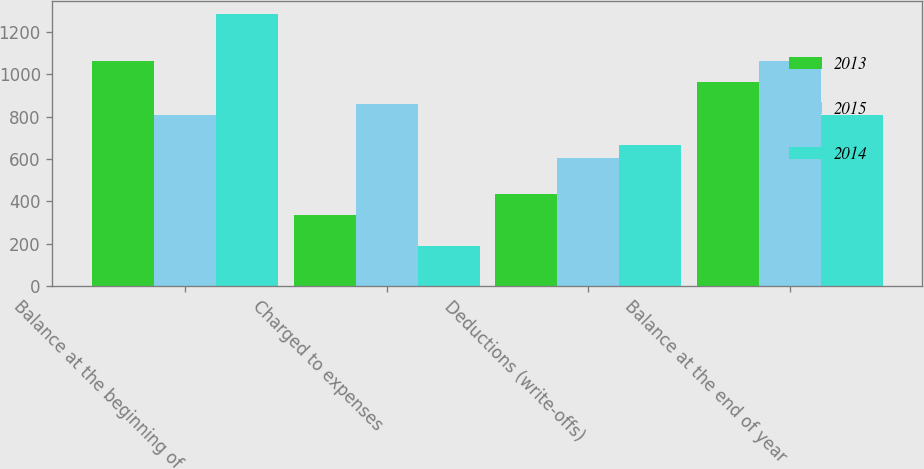<chart> <loc_0><loc_0><loc_500><loc_500><stacked_bar_chart><ecel><fcel>Balance at the beginning of<fcel>Charged to expenses<fcel>Deductions (write-offs)<fcel>Balance at the end of year<nl><fcel>2013<fcel>1063<fcel>335<fcel>435<fcel>963<nl><fcel>2015<fcel>810<fcel>860<fcel>607<fcel>1063<nl><fcel>2014<fcel>1284<fcel>191<fcel>665<fcel>810<nl></chart> 